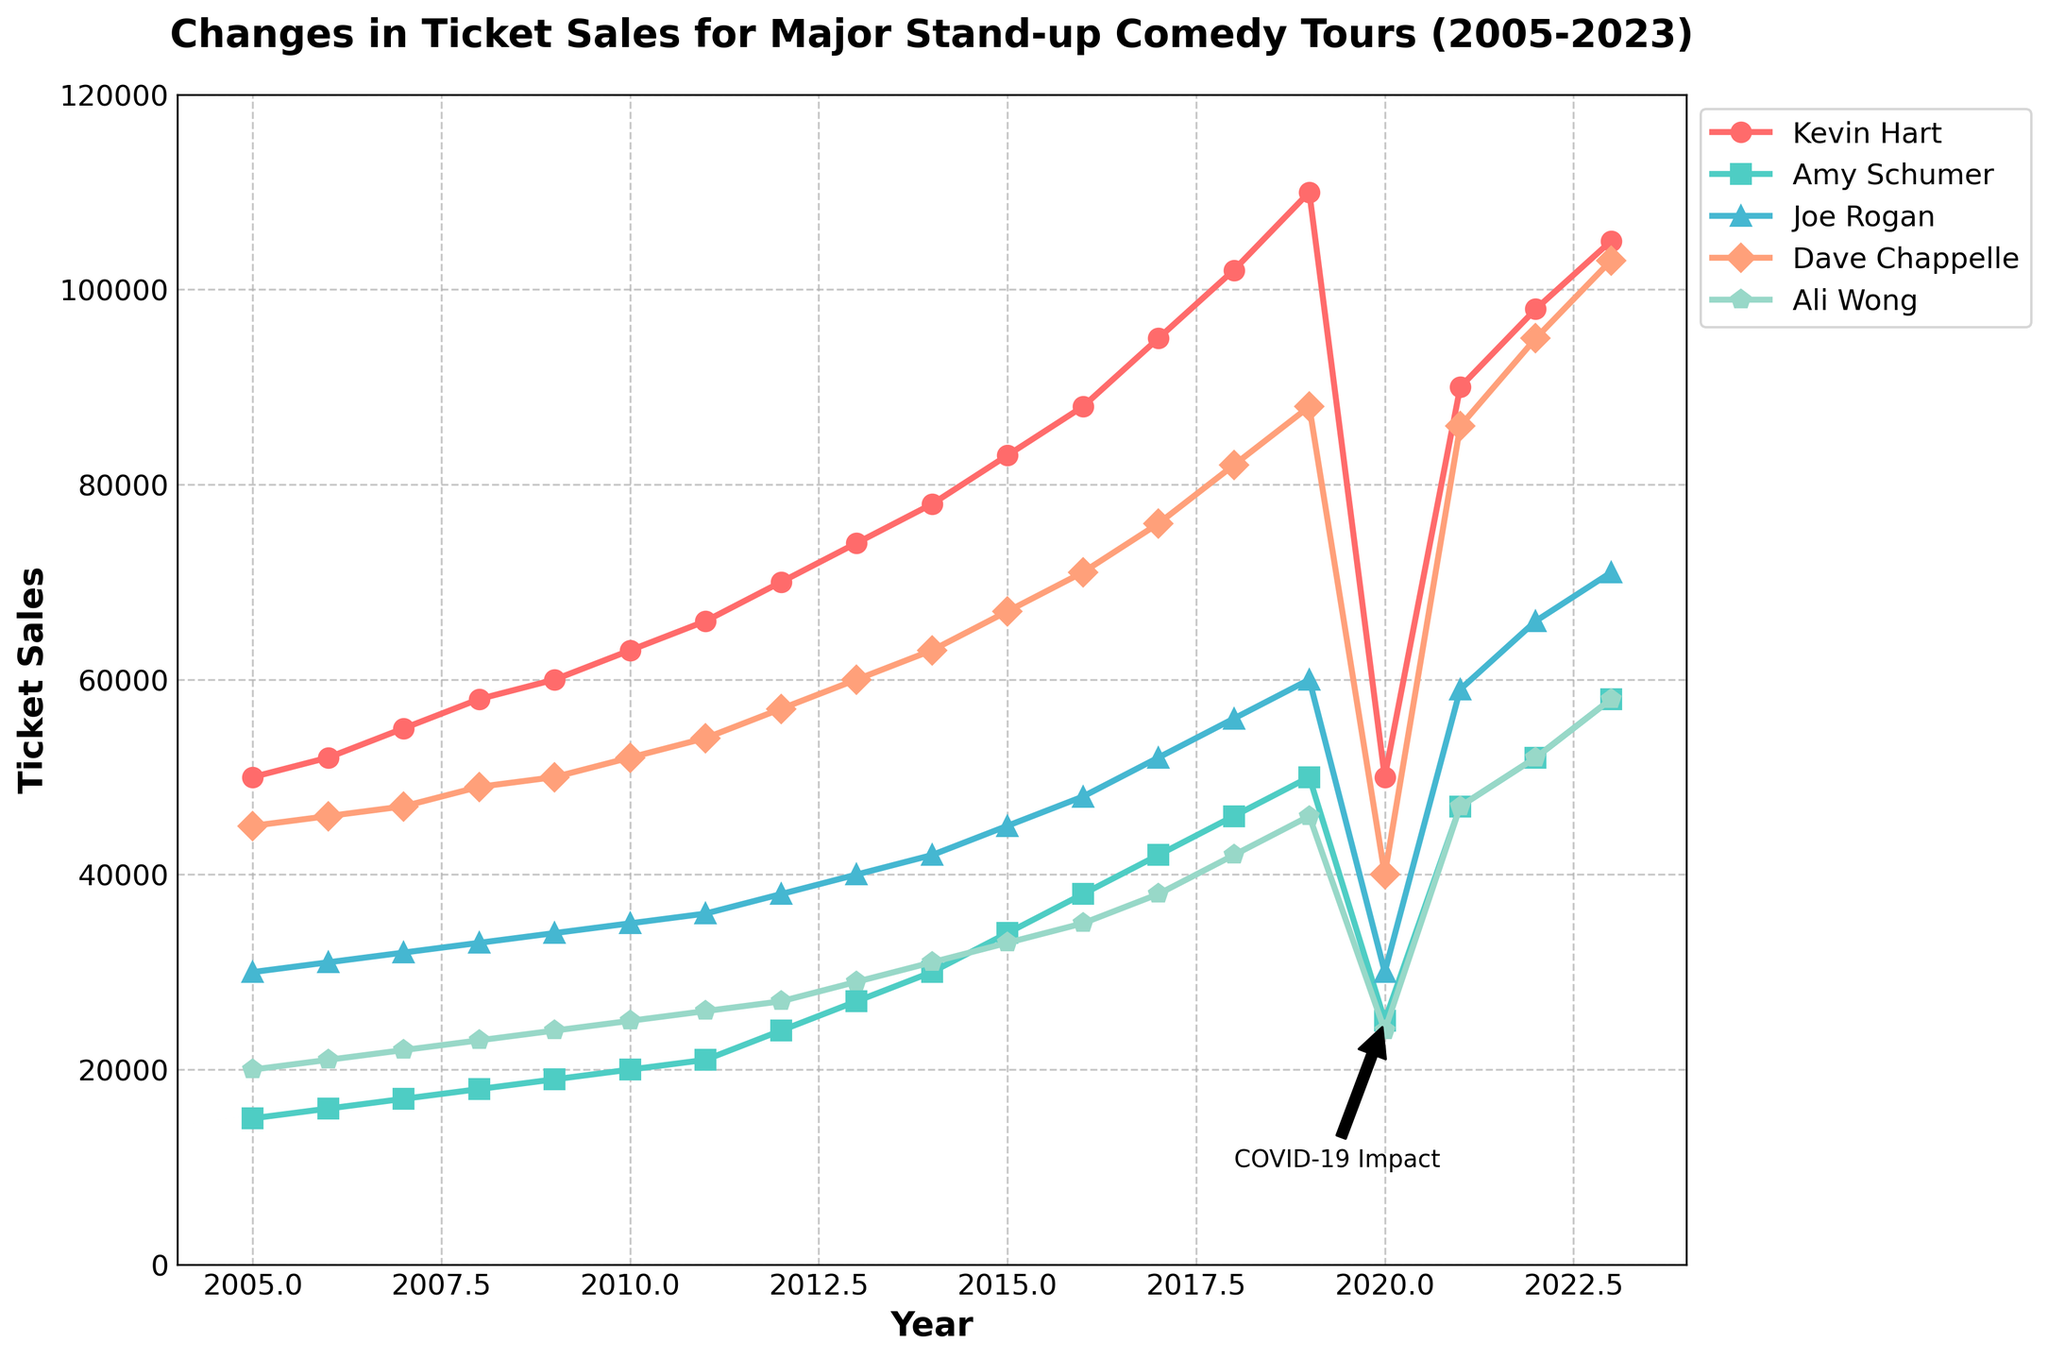What is the title of the figure? Look at the top of the figure, the title is clearly written there. It reads "Changes in Ticket Sales for Major Stand-up Comedy Tours (2005-2023)."
Answer: Changes in Ticket Sales for Major Stand-up Comedy Tours (2005-2023) Which comedian had the highest ticket sales in 2023? Look at the data points for the year 2023, and identify the highest value. Kevin Hart had the highest ticket sales with 105,000 tickets.
Answer: Kevin Hart How did Amy Schumer's ticket sales change from 2019 to 2021? Observe Amy Schumer's ticket sales in 2019 (50,000) and 2021 (47,000). The sales decreased by 3,000 tickets.
Answer: Decreased by 3,000 What was the overall trend in ticket sales for Joe Rogan from 2005 to 2023? Track Joe Rogan's data points from 2005 to 2023. His ticket sales generally increased, with a drop in 2020, but continued to rise afterward.
Answer: Generally increased Who experienced the most significant drop in ticket sales in 2020? Examine the data points in 2020 for each comedian and identify the largest drop compared to 2019. Kevin Hart had the most significant drop, from 110,000 in 2019 to 50,000 in 2020, a decrease of 60,000 tickets.
Answer: Kevin Hart What does the annotation on the plot indicate? Look at the annotation and its label. It points to the year 2020 and labels "COVID-19 Impact," indicating a significant impact on ticket sales.
Answer: COVID-19 Impact In which year did Ali Wong surpass Amy Schumer in ticket sales? Compare Ali Wong and Amy Schumer's ticket sales year by year. In 2021, Ali Wong's ticket sales (47,000) surpassed Amy Schumer's (47,000).
Answer: 2021 What is the general shape of Dave Chappelle's ticket sales trend? Observe the plot of Dave Chappelle's ticket sales. They show a general upward trend with a dip in 2020.
Answer: Upward trend with a dip in 2020 How much did Kevin Hart's ticket sales increase from 2005 to 2023? Subtract the ticket sales in 2005 (50,000) from the ticket sales in 2023 (105,000). The increase is 55,000 tickets.
Answer: Increased by 55,000 Which comedians had ticket sales around 60,000 in 2023? Observe the data points for the year 2023 and identify the comedians with sales near 60,000. Joe Rogan and Ali Wong had sales of 71,000 and 58,000, respectively, which are around 60,000.
Answer: Joe Rogan, Ali Wong 